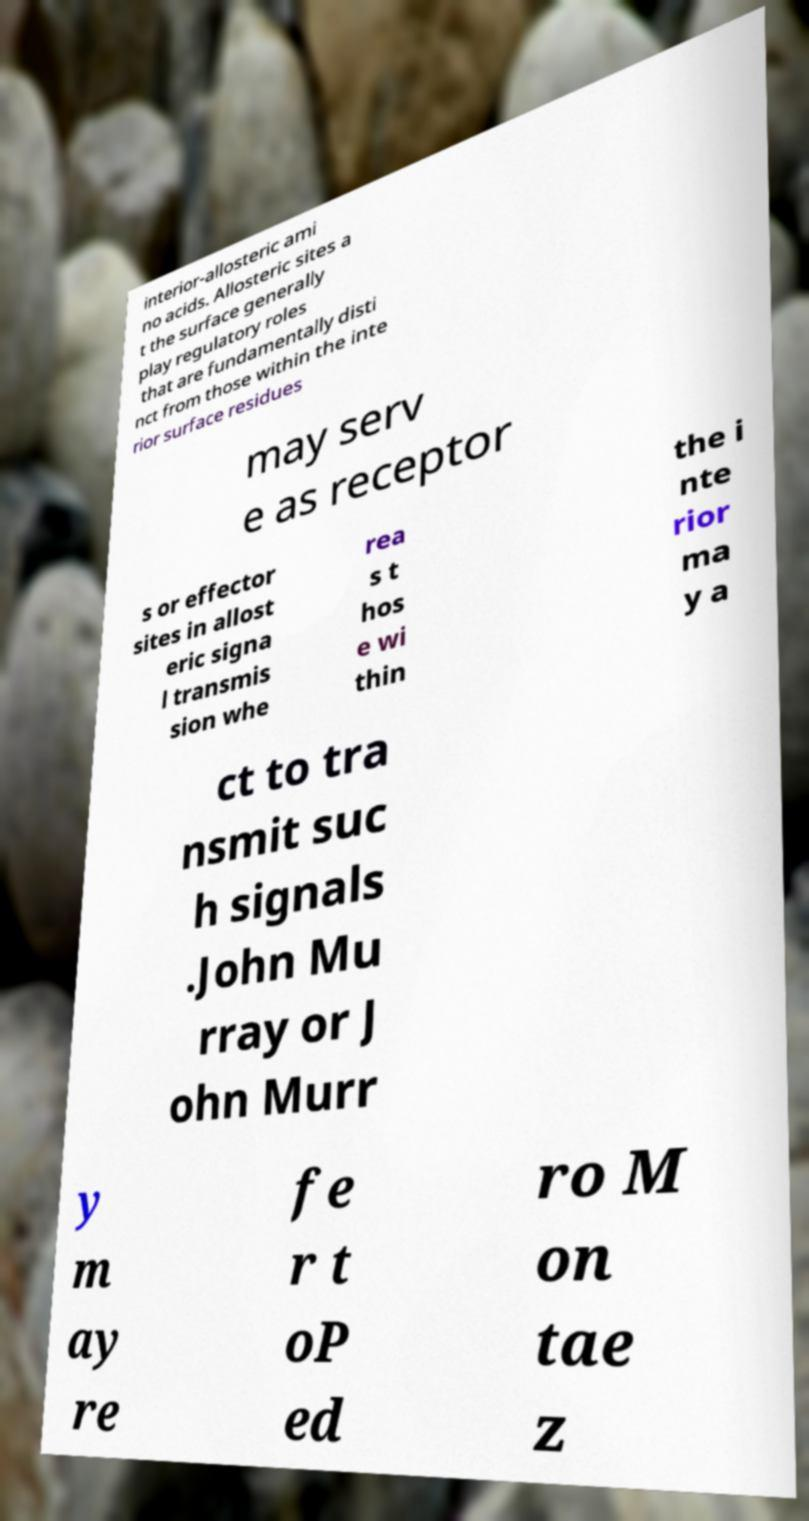I need the written content from this picture converted into text. Can you do that? interior-allosteric ami no acids. Allosteric sites a t the surface generally play regulatory roles that are fundamentally disti nct from those within the inte rior surface residues may serv e as receptor s or effector sites in allost eric signa l transmis sion whe rea s t hos e wi thin the i nte rior ma y a ct to tra nsmit suc h signals .John Mu rray or J ohn Murr y m ay re fe r t oP ed ro M on tae z 